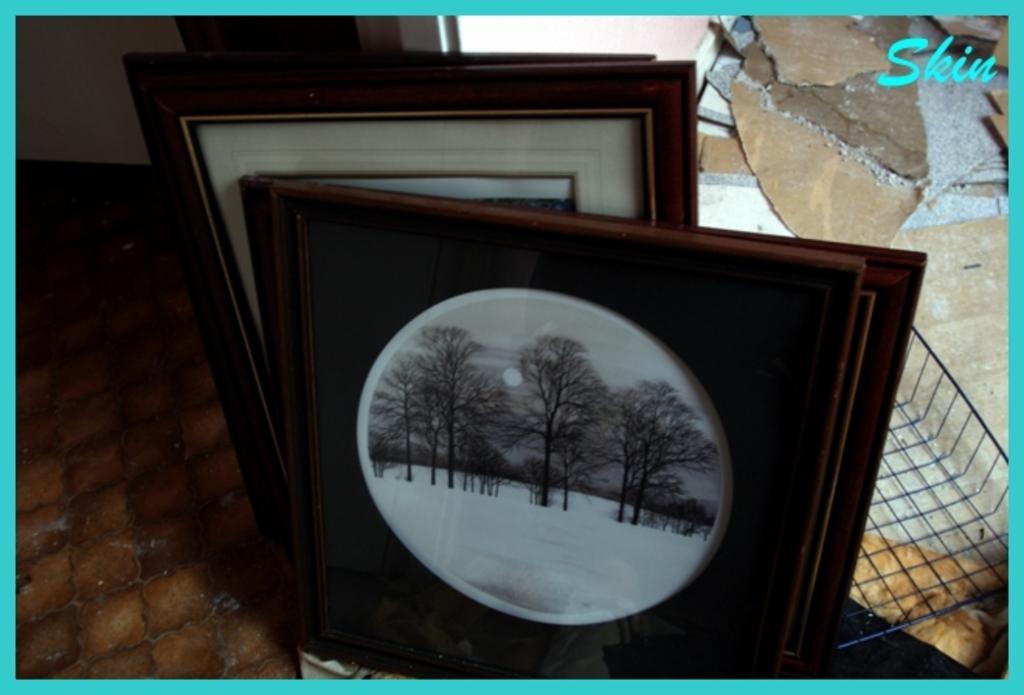Please provide a concise description of this image. In this image there are so many photo frames kept on the floor one after the other beside the wall, also there is an iron grill pan and some text at the top of image. 